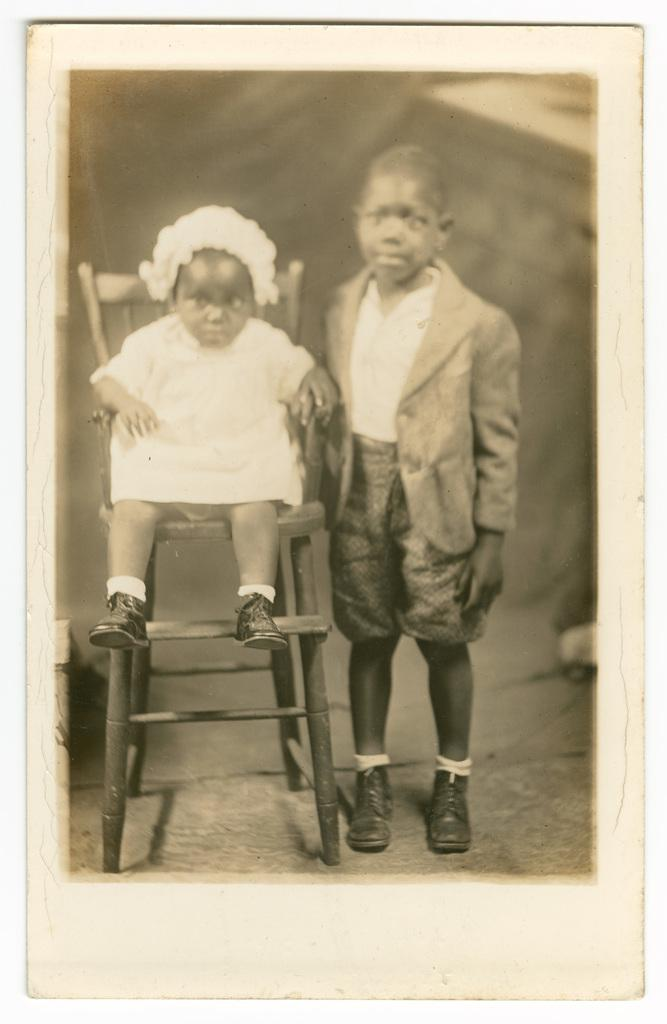What is the child doing in the image? The child is sitting on a chair in the image. Can you describe the boy's position in the image? The boy is standing on a path in the image. What type of food is the child eating in the image? There is no food present in the image; the child is sitting on a chair. What kind of stamp can be seen on the boy's forehead in the image? There is no stamp on the boy's forehead in the image; he is simply standing on a path. 